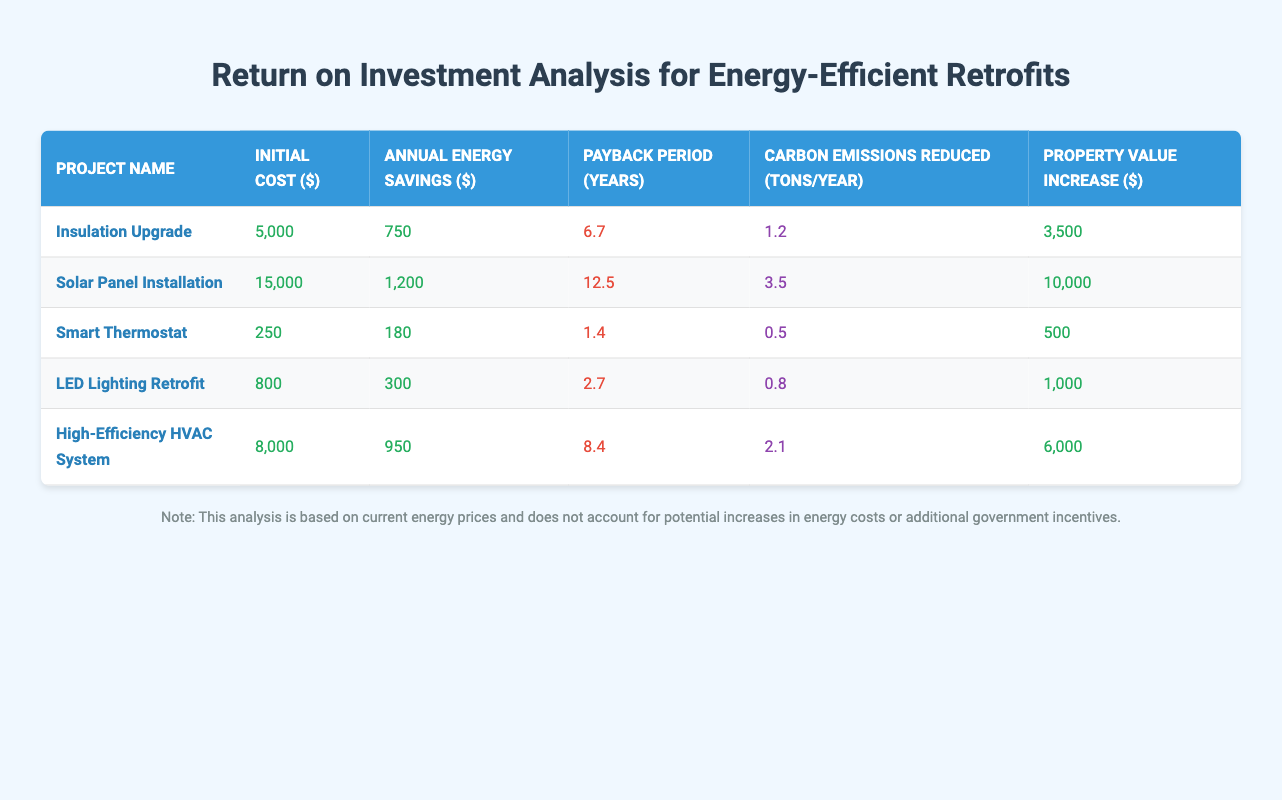What is the initial cost of the Smart Thermostat project? The initial cost of the Smart Thermostat project is listed as $250 in the table under the "Initial Cost" column.
Answer: 250 Which retrofit project has the shortest payback period? The Smart Thermostat has the shortest payback period of 1.4 years, which is lower than the payback periods of the other projects listed in the table.
Answer: Smart Thermostat What is the total annual energy savings from the Insulation Upgrade and LED Lighting Retrofit? The annual energy savings from the Insulation Upgrade is $750, and from the LED Lighting Retrofit is $300. Combining these gives a total of 750 + 300 = $1050.
Answer: 1050 Is the carbon emissions reduced by the Solar Panel Installation greater than that of the Insulation Upgrade? The carbon emissions reduction for the Solar Panel Installation is 3.5 tons/year while for the Insulation Upgrade it is 1.2 tons/year, therefore 3.5 is greater than 1.2, and the statement is true.
Answer: Yes Which retrofit project leads to the highest increase in property value? The Solar Panel Installation leads to the highest property value increase of $10,000 as compared to the other projects, which are all lower than this figure according to the "Property Value Increase" column.
Answer: Solar Panel Installation What is the average initial cost of all retrofit projects? To find the average initial cost, sum the initial costs: 5000 + 15000 + 250 + 800 + 8000 =  23,058. Since there are 5 projects, divide by 5: 23058 / 5 = 4611.6.
Answer: 4611.6 Does the High-Efficiency HVAC System have a higher annual energy savings than the LED Lighting Retrofit? The annual energy savings for the High-Efficiency HVAC System is $950, while the LED Lighting Retrofit provides $300 in savings. Comparing these values, $950 is greater than $300, confirming the statement is true.
Answer: Yes What is the difference in payback periods between the High-Efficiency HVAC System and the Smart Thermostat? The payback period for the High-Efficiency HVAC System is 8.4 years, while for the Smart Thermostat it is 1.4 years. The difference is 8.4 - 1.4 = 7 years.
Answer: 7 What is the total carbon emissions reduction from all retrofit projects combined? The total carbon emissions reduction can be calculated by summing the values: 1.2 + 3.5 + 0.5 + 0.8 + 2.1 = 8.1 tons/year, which gives the total reduction across all projects.
Answer: 8.1 